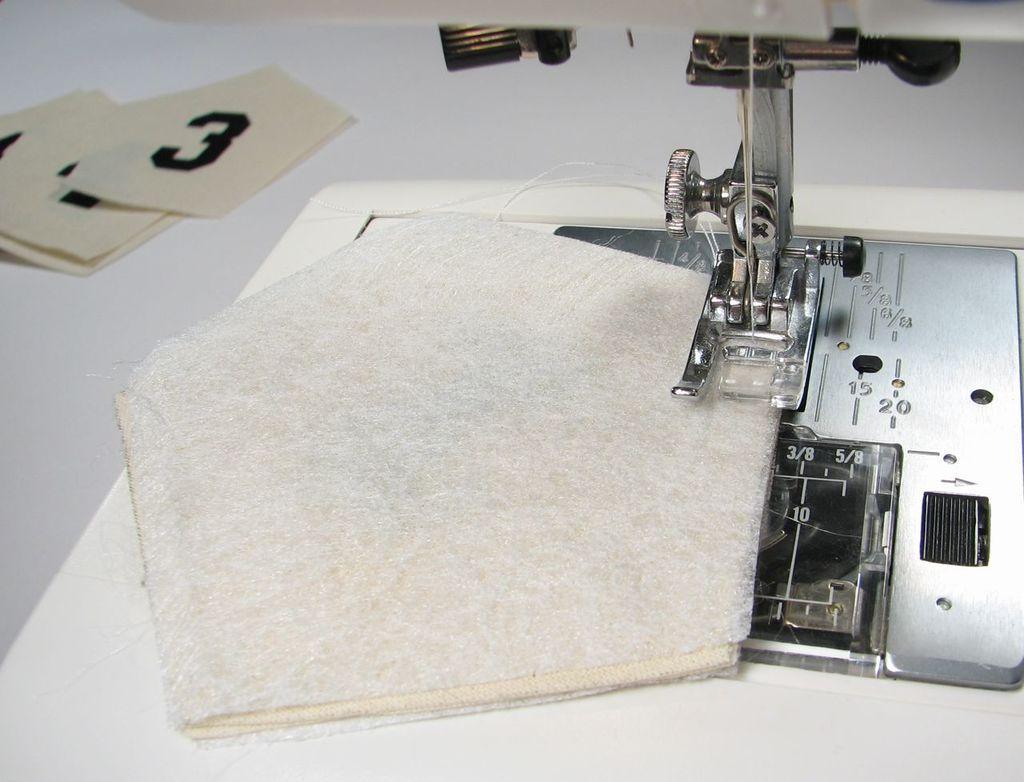Describe this image in one or two sentences. In this picture we can see a cloth on the stitching machine. 